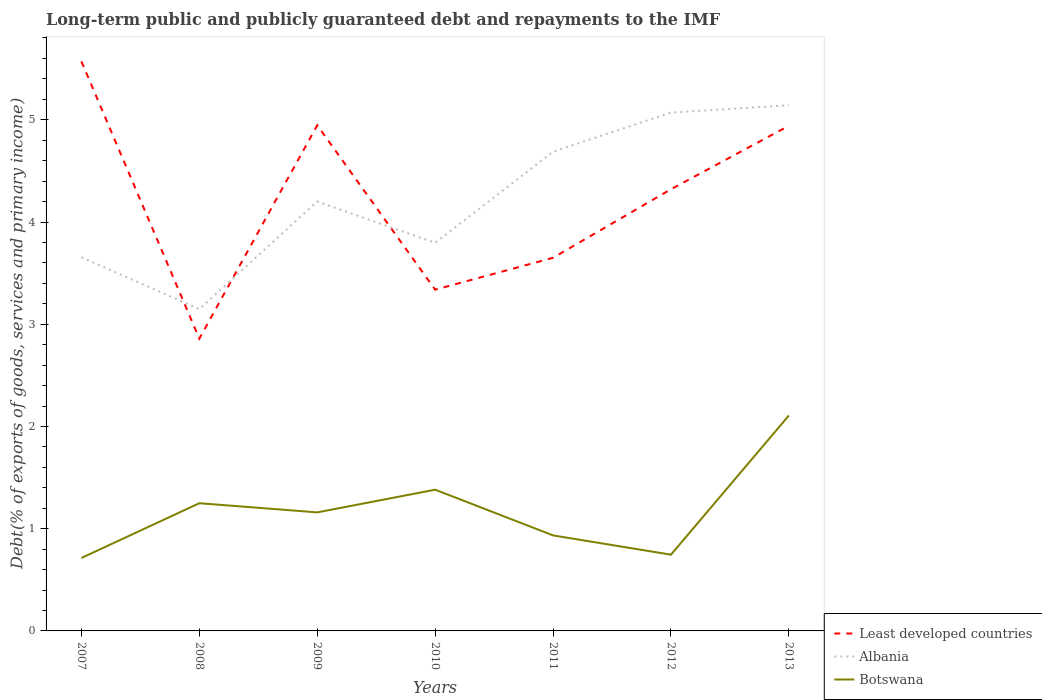Across all years, what is the maximum debt and repayments in Albania?
Ensure brevity in your answer.  3.15. What is the total debt and repayments in Botswana in the graph?
Provide a short and direct response. 0.19. What is the difference between the highest and the second highest debt and repayments in Least developed countries?
Offer a terse response. 2.71. Is the debt and repayments in Albania strictly greater than the debt and repayments in Least developed countries over the years?
Offer a very short reply. No. Does the graph contain any zero values?
Keep it short and to the point. No. Does the graph contain grids?
Offer a terse response. No. Where does the legend appear in the graph?
Offer a very short reply. Bottom right. What is the title of the graph?
Ensure brevity in your answer.  Long-term public and publicly guaranteed debt and repayments to the IMF. What is the label or title of the Y-axis?
Ensure brevity in your answer.  Debt(% of exports of goods, services and primary income). What is the Debt(% of exports of goods, services and primary income) in Least developed countries in 2007?
Make the answer very short. 5.57. What is the Debt(% of exports of goods, services and primary income) of Albania in 2007?
Your answer should be compact. 3.66. What is the Debt(% of exports of goods, services and primary income) in Botswana in 2007?
Your response must be concise. 0.71. What is the Debt(% of exports of goods, services and primary income) in Least developed countries in 2008?
Offer a very short reply. 2.86. What is the Debt(% of exports of goods, services and primary income) in Albania in 2008?
Make the answer very short. 3.15. What is the Debt(% of exports of goods, services and primary income) in Botswana in 2008?
Your answer should be compact. 1.25. What is the Debt(% of exports of goods, services and primary income) in Least developed countries in 2009?
Your response must be concise. 4.95. What is the Debt(% of exports of goods, services and primary income) of Albania in 2009?
Offer a terse response. 4.2. What is the Debt(% of exports of goods, services and primary income) of Botswana in 2009?
Your response must be concise. 1.16. What is the Debt(% of exports of goods, services and primary income) in Least developed countries in 2010?
Offer a very short reply. 3.34. What is the Debt(% of exports of goods, services and primary income) in Albania in 2010?
Provide a succinct answer. 3.8. What is the Debt(% of exports of goods, services and primary income) in Botswana in 2010?
Keep it short and to the point. 1.38. What is the Debt(% of exports of goods, services and primary income) in Least developed countries in 2011?
Ensure brevity in your answer.  3.65. What is the Debt(% of exports of goods, services and primary income) of Albania in 2011?
Your answer should be compact. 4.69. What is the Debt(% of exports of goods, services and primary income) in Botswana in 2011?
Keep it short and to the point. 0.93. What is the Debt(% of exports of goods, services and primary income) of Least developed countries in 2012?
Ensure brevity in your answer.  4.32. What is the Debt(% of exports of goods, services and primary income) in Albania in 2012?
Make the answer very short. 5.07. What is the Debt(% of exports of goods, services and primary income) of Botswana in 2012?
Give a very brief answer. 0.75. What is the Debt(% of exports of goods, services and primary income) of Least developed countries in 2013?
Give a very brief answer. 4.94. What is the Debt(% of exports of goods, services and primary income) in Albania in 2013?
Provide a short and direct response. 5.14. What is the Debt(% of exports of goods, services and primary income) in Botswana in 2013?
Your answer should be compact. 2.11. Across all years, what is the maximum Debt(% of exports of goods, services and primary income) in Least developed countries?
Provide a succinct answer. 5.57. Across all years, what is the maximum Debt(% of exports of goods, services and primary income) in Albania?
Your response must be concise. 5.14. Across all years, what is the maximum Debt(% of exports of goods, services and primary income) of Botswana?
Make the answer very short. 2.11. Across all years, what is the minimum Debt(% of exports of goods, services and primary income) of Least developed countries?
Offer a terse response. 2.86. Across all years, what is the minimum Debt(% of exports of goods, services and primary income) in Albania?
Your response must be concise. 3.15. Across all years, what is the minimum Debt(% of exports of goods, services and primary income) in Botswana?
Keep it short and to the point. 0.71. What is the total Debt(% of exports of goods, services and primary income) in Least developed countries in the graph?
Provide a succinct answer. 29.63. What is the total Debt(% of exports of goods, services and primary income) of Albania in the graph?
Offer a terse response. 29.7. What is the total Debt(% of exports of goods, services and primary income) of Botswana in the graph?
Your response must be concise. 8.29. What is the difference between the Debt(% of exports of goods, services and primary income) in Least developed countries in 2007 and that in 2008?
Offer a very short reply. 2.71. What is the difference between the Debt(% of exports of goods, services and primary income) in Albania in 2007 and that in 2008?
Offer a very short reply. 0.51. What is the difference between the Debt(% of exports of goods, services and primary income) of Botswana in 2007 and that in 2008?
Your response must be concise. -0.54. What is the difference between the Debt(% of exports of goods, services and primary income) of Least developed countries in 2007 and that in 2009?
Provide a short and direct response. 0.62. What is the difference between the Debt(% of exports of goods, services and primary income) in Albania in 2007 and that in 2009?
Make the answer very short. -0.55. What is the difference between the Debt(% of exports of goods, services and primary income) of Botswana in 2007 and that in 2009?
Provide a short and direct response. -0.45. What is the difference between the Debt(% of exports of goods, services and primary income) of Least developed countries in 2007 and that in 2010?
Your response must be concise. 2.23. What is the difference between the Debt(% of exports of goods, services and primary income) in Albania in 2007 and that in 2010?
Give a very brief answer. -0.14. What is the difference between the Debt(% of exports of goods, services and primary income) in Botswana in 2007 and that in 2010?
Provide a short and direct response. -0.67. What is the difference between the Debt(% of exports of goods, services and primary income) of Least developed countries in 2007 and that in 2011?
Your response must be concise. 1.92. What is the difference between the Debt(% of exports of goods, services and primary income) in Albania in 2007 and that in 2011?
Provide a succinct answer. -1.03. What is the difference between the Debt(% of exports of goods, services and primary income) of Botswana in 2007 and that in 2011?
Your answer should be very brief. -0.22. What is the difference between the Debt(% of exports of goods, services and primary income) of Least developed countries in 2007 and that in 2012?
Ensure brevity in your answer.  1.25. What is the difference between the Debt(% of exports of goods, services and primary income) of Albania in 2007 and that in 2012?
Give a very brief answer. -1.42. What is the difference between the Debt(% of exports of goods, services and primary income) of Botswana in 2007 and that in 2012?
Give a very brief answer. -0.03. What is the difference between the Debt(% of exports of goods, services and primary income) of Least developed countries in 2007 and that in 2013?
Offer a very short reply. 0.63. What is the difference between the Debt(% of exports of goods, services and primary income) of Albania in 2007 and that in 2013?
Offer a terse response. -1.49. What is the difference between the Debt(% of exports of goods, services and primary income) in Botswana in 2007 and that in 2013?
Your answer should be very brief. -1.39. What is the difference between the Debt(% of exports of goods, services and primary income) in Least developed countries in 2008 and that in 2009?
Keep it short and to the point. -2.09. What is the difference between the Debt(% of exports of goods, services and primary income) in Albania in 2008 and that in 2009?
Make the answer very short. -1.05. What is the difference between the Debt(% of exports of goods, services and primary income) of Botswana in 2008 and that in 2009?
Offer a very short reply. 0.09. What is the difference between the Debt(% of exports of goods, services and primary income) in Least developed countries in 2008 and that in 2010?
Your response must be concise. -0.48. What is the difference between the Debt(% of exports of goods, services and primary income) of Albania in 2008 and that in 2010?
Keep it short and to the point. -0.65. What is the difference between the Debt(% of exports of goods, services and primary income) of Botswana in 2008 and that in 2010?
Make the answer very short. -0.13. What is the difference between the Debt(% of exports of goods, services and primary income) of Least developed countries in 2008 and that in 2011?
Your response must be concise. -0.79. What is the difference between the Debt(% of exports of goods, services and primary income) in Albania in 2008 and that in 2011?
Offer a terse response. -1.54. What is the difference between the Debt(% of exports of goods, services and primary income) in Botswana in 2008 and that in 2011?
Ensure brevity in your answer.  0.31. What is the difference between the Debt(% of exports of goods, services and primary income) in Least developed countries in 2008 and that in 2012?
Ensure brevity in your answer.  -1.46. What is the difference between the Debt(% of exports of goods, services and primary income) of Albania in 2008 and that in 2012?
Your answer should be compact. -1.92. What is the difference between the Debt(% of exports of goods, services and primary income) of Botswana in 2008 and that in 2012?
Your response must be concise. 0.5. What is the difference between the Debt(% of exports of goods, services and primary income) in Least developed countries in 2008 and that in 2013?
Offer a very short reply. -2.08. What is the difference between the Debt(% of exports of goods, services and primary income) in Albania in 2008 and that in 2013?
Your answer should be compact. -1.99. What is the difference between the Debt(% of exports of goods, services and primary income) of Botswana in 2008 and that in 2013?
Ensure brevity in your answer.  -0.86. What is the difference between the Debt(% of exports of goods, services and primary income) in Least developed countries in 2009 and that in 2010?
Give a very brief answer. 1.61. What is the difference between the Debt(% of exports of goods, services and primary income) of Albania in 2009 and that in 2010?
Provide a short and direct response. 0.4. What is the difference between the Debt(% of exports of goods, services and primary income) of Botswana in 2009 and that in 2010?
Provide a succinct answer. -0.22. What is the difference between the Debt(% of exports of goods, services and primary income) of Least developed countries in 2009 and that in 2011?
Provide a short and direct response. 1.3. What is the difference between the Debt(% of exports of goods, services and primary income) of Albania in 2009 and that in 2011?
Your answer should be very brief. -0.49. What is the difference between the Debt(% of exports of goods, services and primary income) of Botswana in 2009 and that in 2011?
Make the answer very short. 0.23. What is the difference between the Debt(% of exports of goods, services and primary income) in Least developed countries in 2009 and that in 2012?
Ensure brevity in your answer.  0.63. What is the difference between the Debt(% of exports of goods, services and primary income) in Albania in 2009 and that in 2012?
Give a very brief answer. -0.87. What is the difference between the Debt(% of exports of goods, services and primary income) in Botswana in 2009 and that in 2012?
Your answer should be compact. 0.41. What is the difference between the Debt(% of exports of goods, services and primary income) in Least developed countries in 2009 and that in 2013?
Your response must be concise. 0. What is the difference between the Debt(% of exports of goods, services and primary income) of Albania in 2009 and that in 2013?
Offer a very short reply. -0.94. What is the difference between the Debt(% of exports of goods, services and primary income) of Botswana in 2009 and that in 2013?
Offer a very short reply. -0.95. What is the difference between the Debt(% of exports of goods, services and primary income) in Least developed countries in 2010 and that in 2011?
Provide a succinct answer. -0.31. What is the difference between the Debt(% of exports of goods, services and primary income) of Albania in 2010 and that in 2011?
Offer a terse response. -0.89. What is the difference between the Debt(% of exports of goods, services and primary income) of Botswana in 2010 and that in 2011?
Your answer should be very brief. 0.45. What is the difference between the Debt(% of exports of goods, services and primary income) in Least developed countries in 2010 and that in 2012?
Make the answer very short. -0.98. What is the difference between the Debt(% of exports of goods, services and primary income) of Albania in 2010 and that in 2012?
Your response must be concise. -1.27. What is the difference between the Debt(% of exports of goods, services and primary income) in Botswana in 2010 and that in 2012?
Your answer should be compact. 0.64. What is the difference between the Debt(% of exports of goods, services and primary income) of Least developed countries in 2010 and that in 2013?
Provide a short and direct response. -1.6. What is the difference between the Debt(% of exports of goods, services and primary income) of Albania in 2010 and that in 2013?
Your answer should be compact. -1.35. What is the difference between the Debt(% of exports of goods, services and primary income) of Botswana in 2010 and that in 2013?
Give a very brief answer. -0.73. What is the difference between the Debt(% of exports of goods, services and primary income) of Least developed countries in 2011 and that in 2012?
Your answer should be compact. -0.67. What is the difference between the Debt(% of exports of goods, services and primary income) in Albania in 2011 and that in 2012?
Offer a very short reply. -0.38. What is the difference between the Debt(% of exports of goods, services and primary income) of Botswana in 2011 and that in 2012?
Your answer should be very brief. 0.19. What is the difference between the Debt(% of exports of goods, services and primary income) in Least developed countries in 2011 and that in 2013?
Provide a short and direct response. -1.29. What is the difference between the Debt(% of exports of goods, services and primary income) in Albania in 2011 and that in 2013?
Your response must be concise. -0.45. What is the difference between the Debt(% of exports of goods, services and primary income) of Botswana in 2011 and that in 2013?
Offer a very short reply. -1.17. What is the difference between the Debt(% of exports of goods, services and primary income) in Least developed countries in 2012 and that in 2013?
Offer a very short reply. -0.62. What is the difference between the Debt(% of exports of goods, services and primary income) of Albania in 2012 and that in 2013?
Give a very brief answer. -0.07. What is the difference between the Debt(% of exports of goods, services and primary income) of Botswana in 2012 and that in 2013?
Provide a short and direct response. -1.36. What is the difference between the Debt(% of exports of goods, services and primary income) in Least developed countries in 2007 and the Debt(% of exports of goods, services and primary income) in Albania in 2008?
Provide a short and direct response. 2.42. What is the difference between the Debt(% of exports of goods, services and primary income) in Least developed countries in 2007 and the Debt(% of exports of goods, services and primary income) in Botswana in 2008?
Your response must be concise. 4.32. What is the difference between the Debt(% of exports of goods, services and primary income) in Albania in 2007 and the Debt(% of exports of goods, services and primary income) in Botswana in 2008?
Your response must be concise. 2.41. What is the difference between the Debt(% of exports of goods, services and primary income) in Least developed countries in 2007 and the Debt(% of exports of goods, services and primary income) in Albania in 2009?
Make the answer very short. 1.37. What is the difference between the Debt(% of exports of goods, services and primary income) in Least developed countries in 2007 and the Debt(% of exports of goods, services and primary income) in Botswana in 2009?
Provide a succinct answer. 4.41. What is the difference between the Debt(% of exports of goods, services and primary income) in Albania in 2007 and the Debt(% of exports of goods, services and primary income) in Botswana in 2009?
Offer a very short reply. 2.5. What is the difference between the Debt(% of exports of goods, services and primary income) of Least developed countries in 2007 and the Debt(% of exports of goods, services and primary income) of Albania in 2010?
Offer a terse response. 1.77. What is the difference between the Debt(% of exports of goods, services and primary income) in Least developed countries in 2007 and the Debt(% of exports of goods, services and primary income) in Botswana in 2010?
Make the answer very short. 4.19. What is the difference between the Debt(% of exports of goods, services and primary income) of Albania in 2007 and the Debt(% of exports of goods, services and primary income) of Botswana in 2010?
Make the answer very short. 2.27. What is the difference between the Debt(% of exports of goods, services and primary income) in Least developed countries in 2007 and the Debt(% of exports of goods, services and primary income) in Albania in 2011?
Your response must be concise. 0.88. What is the difference between the Debt(% of exports of goods, services and primary income) in Least developed countries in 2007 and the Debt(% of exports of goods, services and primary income) in Botswana in 2011?
Provide a short and direct response. 4.64. What is the difference between the Debt(% of exports of goods, services and primary income) of Albania in 2007 and the Debt(% of exports of goods, services and primary income) of Botswana in 2011?
Your answer should be very brief. 2.72. What is the difference between the Debt(% of exports of goods, services and primary income) in Least developed countries in 2007 and the Debt(% of exports of goods, services and primary income) in Albania in 2012?
Ensure brevity in your answer.  0.5. What is the difference between the Debt(% of exports of goods, services and primary income) in Least developed countries in 2007 and the Debt(% of exports of goods, services and primary income) in Botswana in 2012?
Your answer should be very brief. 4.83. What is the difference between the Debt(% of exports of goods, services and primary income) in Albania in 2007 and the Debt(% of exports of goods, services and primary income) in Botswana in 2012?
Offer a very short reply. 2.91. What is the difference between the Debt(% of exports of goods, services and primary income) of Least developed countries in 2007 and the Debt(% of exports of goods, services and primary income) of Albania in 2013?
Ensure brevity in your answer.  0.43. What is the difference between the Debt(% of exports of goods, services and primary income) in Least developed countries in 2007 and the Debt(% of exports of goods, services and primary income) in Botswana in 2013?
Ensure brevity in your answer.  3.46. What is the difference between the Debt(% of exports of goods, services and primary income) of Albania in 2007 and the Debt(% of exports of goods, services and primary income) of Botswana in 2013?
Ensure brevity in your answer.  1.55. What is the difference between the Debt(% of exports of goods, services and primary income) in Least developed countries in 2008 and the Debt(% of exports of goods, services and primary income) in Albania in 2009?
Make the answer very short. -1.34. What is the difference between the Debt(% of exports of goods, services and primary income) in Least developed countries in 2008 and the Debt(% of exports of goods, services and primary income) in Botswana in 2009?
Offer a terse response. 1.7. What is the difference between the Debt(% of exports of goods, services and primary income) in Albania in 2008 and the Debt(% of exports of goods, services and primary income) in Botswana in 2009?
Your answer should be very brief. 1.99. What is the difference between the Debt(% of exports of goods, services and primary income) of Least developed countries in 2008 and the Debt(% of exports of goods, services and primary income) of Albania in 2010?
Give a very brief answer. -0.94. What is the difference between the Debt(% of exports of goods, services and primary income) in Least developed countries in 2008 and the Debt(% of exports of goods, services and primary income) in Botswana in 2010?
Offer a very short reply. 1.48. What is the difference between the Debt(% of exports of goods, services and primary income) of Albania in 2008 and the Debt(% of exports of goods, services and primary income) of Botswana in 2010?
Your response must be concise. 1.77. What is the difference between the Debt(% of exports of goods, services and primary income) of Least developed countries in 2008 and the Debt(% of exports of goods, services and primary income) of Albania in 2011?
Ensure brevity in your answer.  -1.83. What is the difference between the Debt(% of exports of goods, services and primary income) of Least developed countries in 2008 and the Debt(% of exports of goods, services and primary income) of Botswana in 2011?
Provide a succinct answer. 1.92. What is the difference between the Debt(% of exports of goods, services and primary income) in Albania in 2008 and the Debt(% of exports of goods, services and primary income) in Botswana in 2011?
Your response must be concise. 2.21. What is the difference between the Debt(% of exports of goods, services and primary income) in Least developed countries in 2008 and the Debt(% of exports of goods, services and primary income) in Albania in 2012?
Keep it short and to the point. -2.21. What is the difference between the Debt(% of exports of goods, services and primary income) in Least developed countries in 2008 and the Debt(% of exports of goods, services and primary income) in Botswana in 2012?
Keep it short and to the point. 2.11. What is the difference between the Debt(% of exports of goods, services and primary income) of Albania in 2008 and the Debt(% of exports of goods, services and primary income) of Botswana in 2012?
Make the answer very short. 2.4. What is the difference between the Debt(% of exports of goods, services and primary income) in Least developed countries in 2008 and the Debt(% of exports of goods, services and primary income) in Albania in 2013?
Your response must be concise. -2.28. What is the difference between the Debt(% of exports of goods, services and primary income) of Least developed countries in 2008 and the Debt(% of exports of goods, services and primary income) of Botswana in 2013?
Provide a succinct answer. 0.75. What is the difference between the Debt(% of exports of goods, services and primary income) in Albania in 2008 and the Debt(% of exports of goods, services and primary income) in Botswana in 2013?
Provide a succinct answer. 1.04. What is the difference between the Debt(% of exports of goods, services and primary income) of Least developed countries in 2009 and the Debt(% of exports of goods, services and primary income) of Albania in 2010?
Keep it short and to the point. 1.15. What is the difference between the Debt(% of exports of goods, services and primary income) in Least developed countries in 2009 and the Debt(% of exports of goods, services and primary income) in Botswana in 2010?
Offer a terse response. 3.56. What is the difference between the Debt(% of exports of goods, services and primary income) of Albania in 2009 and the Debt(% of exports of goods, services and primary income) of Botswana in 2010?
Offer a very short reply. 2.82. What is the difference between the Debt(% of exports of goods, services and primary income) of Least developed countries in 2009 and the Debt(% of exports of goods, services and primary income) of Albania in 2011?
Your response must be concise. 0.26. What is the difference between the Debt(% of exports of goods, services and primary income) of Least developed countries in 2009 and the Debt(% of exports of goods, services and primary income) of Botswana in 2011?
Offer a very short reply. 4.01. What is the difference between the Debt(% of exports of goods, services and primary income) of Albania in 2009 and the Debt(% of exports of goods, services and primary income) of Botswana in 2011?
Keep it short and to the point. 3.27. What is the difference between the Debt(% of exports of goods, services and primary income) in Least developed countries in 2009 and the Debt(% of exports of goods, services and primary income) in Albania in 2012?
Your answer should be very brief. -0.12. What is the difference between the Debt(% of exports of goods, services and primary income) in Least developed countries in 2009 and the Debt(% of exports of goods, services and primary income) in Botswana in 2012?
Ensure brevity in your answer.  4.2. What is the difference between the Debt(% of exports of goods, services and primary income) of Albania in 2009 and the Debt(% of exports of goods, services and primary income) of Botswana in 2012?
Your answer should be very brief. 3.45. What is the difference between the Debt(% of exports of goods, services and primary income) in Least developed countries in 2009 and the Debt(% of exports of goods, services and primary income) in Albania in 2013?
Offer a very short reply. -0.2. What is the difference between the Debt(% of exports of goods, services and primary income) in Least developed countries in 2009 and the Debt(% of exports of goods, services and primary income) in Botswana in 2013?
Offer a very short reply. 2.84. What is the difference between the Debt(% of exports of goods, services and primary income) of Albania in 2009 and the Debt(% of exports of goods, services and primary income) of Botswana in 2013?
Your answer should be compact. 2.09. What is the difference between the Debt(% of exports of goods, services and primary income) in Least developed countries in 2010 and the Debt(% of exports of goods, services and primary income) in Albania in 2011?
Provide a succinct answer. -1.35. What is the difference between the Debt(% of exports of goods, services and primary income) of Least developed countries in 2010 and the Debt(% of exports of goods, services and primary income) of Botswana in 2011?
Give a very brief answer. 2.4. What is the difference between the Debt(% of exports of goods, services and primary income) in Albania in 2010 and the Debt(% of exports of goods, services and primary income) in Botswana in 2011?
Ensure brevity in your answer.  2.86. What is the difference between the Debt(% of exports of goods, services and primary income) in Least developed countries in 2010 and the Debt(% of exports of goods, services and primary income) in Albania in 2012?
Your answer should be compact. -1.73. What is the difference between the Debt(% of exports of goods, services and primary income) of Least developed countries in 2010 and the Debt(% of exports of goods, services and primary income) of Botswana in 2012?
Keep it short and to the point. 2.59. What is the difference between the Debt(% of exports of goods, services and primary income) of Albania in 2010 and the Debt(% of exports of goods, services and primary income) of Botswana in 2012?
Your answer should be very brief. 3.05. What is the difference between the Debt(% of exports of goods, services and primary income) of Least developed countries in 2010 and the Debt(% of exports of goods, services and primary income) of Albania in 2013?
Make the answer very short. -1.8. What is the difference between the Debt(% of exports of goods, services and primary income) in Least developed countries in 2010 and the Debt(% of exports of goods, services and primary income) in Botswana in 2013?
Keep it short and to the point. 1.23. What is the difference between the Debt(% of exports of goods, services and primary income) of Albania in 2010 and the Debt(% of exports of goods, services and primary income) of Botswana in 2013?
Your answer should be very brief. 1.69. What is the difference between the Debt(% of exports of goods, services and primary income) in Least developed countries in 2011 and the Debt(% of exports of goods, services and primary income) in Albania in 2012?
Keep it short and to the point. -1.42. What is the difference between the Debt(% of exports of goods, services and primary income) in Least developed countries in 2011 and the Debt(% of exports of goods, services and primary income) in Botswana in 2012?
Give a very brief answer. 2.9. What is the difference between the Debt(% of exports of goods, services and primary income) in Albania in 2011 and the Debt(% of exports of goods, services and primary income) in Botswana in 2012?
Offer a terse response. 3.94. What is the difference between the Debt(% of exports of goods, services and primary income) in Least developed countries in 2011 and the Debt(% of exports of goods, services and primary income) in Albania in 2013?
Offer a very short reply. -1.49. What is the difference between the Debt(% of exports of goods, services and primary income) in Least developed countries in 2011 and the Debt(% of exports of goods, services and primary income) in Botswana in 2013?
Provide a short and direct response. 1.54. What is the difference between the Debt(% of exports of goods, services and primary income) of Albania in 2011 and the Debt(% of exports of goods, services and primary income) of Botswana in 2013?
Offer a terse response. 2.58. What is the difference between the Debt(% of exports of goods, services and primary income) of Least developed countries in 2012 and the Debt(% of exports of goods, services and primary income) of Albania in 2013?
Offer a very short reply. -0.82. What is the difference between the Debt(% of exports of goods, services and primary income) in Least developed countries in 2012 and the Debt(% of exports of goods, services and primary income) in Botswana in 2013?
Your answer should be compact. 2.21. What is the difference between the Debt(% of exports of goods, services and primary income) of Albania in 2012 and the Debt(% of exports of goods, services and primary income) of Botswana in 2013?
Your answer should be compact. 2.96. What is the average Debt(% of exports of goods, services and primary income) of Least developed countries per year?
Give a very brief answer. 4.23. What is the average Debt(% of exports of goods, services and primary income) of Albania per year?
Provide a succinct answer. 4.24. What is the average Debt(% of exports of goods, services and primary income) of Botswana per year?
Make the answer very short. 1.18. In the year 2007, what is the difference between the Debt(% of exports of goods, services and primary income) of Least developed countries and Debt(% of exports of goods, services and primary income) of Albania?
Keep it short and to the point. 1.92. In the year 2007, what is the difference between the Debt(% of exports of goods, services and primary income) of Least developed countries and Debt(% of exports of goods, services and primary income) of Botswana?
Provide a succinct answer. 4.86. In the year 2007, what is the difference between the Debt(% of exports of goods, services and primary income) in Albania and Debt(% of exports of goods, services and primary income) in Botswana?
Provide a succinct answer. 2.94. In the year 2008, what is the difference between the Debt(% of exports of goods, services and primary income) in Least developed countries and Debt(% of exports of goods, services and primary income) in Albania?
Provide a short and direct response. -0.29. In the year 2008, what is the difference between the Debt(% of exports of goods, services and primary income) of Least developed countries and Debt(% of exports of goods, services and primary income) of Botswana?
Your answer should be very brief. 1.61. In the year 2008, what is the difference between the Debt(% of exports of goods, services and primary income) in Albania and Debt(% of exports of goods, services and primary income) in Botswana?
Keep it short and to the point. 1.9. In the year 2009, what is the difference between the Debt(% of exports of goods, services and primary income) of Least developed countries and Debt(% of exports of goods, services and primary income) of Albania?
Your answer should be very brief. 0.75. In the year 2009, what is the difference between the Debt(% of exports of goods, services and primary income) in Least developed countries and Debt(% of exports of goods, services and primary income) in Botswana?
Provide a short and direct response. 3.79. In the year 2009, what is the difference between the Debt(% of exports of goods, services and primary income) of Albania and Debt(% of exports of goods, services and primary income) of Botswana?
Provide a short and direct response. 3.04. In the year 2010, what is the difference between the Debt(% of exports of goods, services and primary income) of Least developed countries and Debt(% of exports of goods, services and primary income) of Albania?
Make the answer very short. -0.46. In the year 2010, what is the difference between the Debt(% of exports of goods, services and primary income) in Least developed countries and Debt(% of exports of goods, services and primary income) in Botswana?
Keep it short and to the point. 1.96. In the year 2010, what is the difference between the Debt(% of exports of goods, services and primary income) in Albania and Debt(% of exports of goods, services and primary income) in Botswana?
Your response must be concise. 2.42. In the year 2011, what is the difference between the Debt(% of exports of goods, services and primary income) in Least developed countries and Debt(% of exports of goods, services and primary income) in Albania?
Make the answer very short. -1.04. In the year 2011, what is the difference between the Debt(% of exports of goods, services and primary income) of Least developed countries and Debt(% of exports of goods, services and primary income) of Botswana?
Provide a succinct answer. 2.72. In the year 2011, what is the difference between the Debt(% of exports of goods, services and primary income) in Albania and Debt(% of exports of goods, services and primary income) in Botswana?
Provide a short and direct response. 3.75. In the year 2012, what is the difference between the Debt(% of exports of goods, services and primary income) of Least developed countries and Debt(% of exports of goods, services and primary income) of Albania?
Keep it short and to the point. -0.75. In the year 2012, what is the difference between the Debt(% of exports of goods, services and primary income) of Least developed countries and Debt(% of exports of goods, services and primary income) of Botswana?
Ensure brevity in your answer.  3.57. In the year 2012, what is the difference between the Debt(% of exports of goods, services and primary income) in Albania and Debt(% of exports of goods, services and primary income) in Botswana?
Your response must be concise. 4.32. In the year 2013, what is the difference between the Debt(% of exports of goods, services and primary income) of Least developed countries and Debt(% of exports of goods, services and primary income) of Albania?
Ensure brevity in your answer.  -0.2. In the year 2013, what is the difference between the Debt(% of exports of goods, services and primary income) of Least developed countries and Debt(% of exports of goods, services and primary income) of Botswana?
Your answer should be very brief. 2.83. In the year 2013, what is the difference between the Debt(% of exports of goods, services and primary income) of Albania and Debt(% of exports of goods, services and primary income) of Botswana?
Offer a very short reply. 3.03. What is the ratio of the Debt(% of exports of goods, services and primary income) in Least developed countries in 2007 to that in 2008?
Give a very brief answer. 1.95. What is the ratio of the Debt(% of exports of goods, services and primary income) of Albania in 2007 to that in 2008?
Provide a short and direct response. 1.16. What is the ratio of the Debt(% of exports of goods, services and primary income) in Botswana in 2007 to that in 2008?
Ensure brevity in your answer.  0.57. What is the ratio of the Debt(% of exports of goods, services and primary income) of Least developed countries in 2007 to that in 2009?
Your answer should be very brief. 1.13. What is the ratio of the Debt(% of exports of goods, services and primary income) in Albania in 2007 to that in 2009?
Your answer should be very brief. 0.87. What is the ratio of the Debt(% of exports of goods, services and primary income) in Botswana in 2007 to that in 2009?
Keep it short and to the point. 0.62. What is the ratio of the Debt(% of exports of goods, services and primary income) in Least developed countries in 2007 to that in 2010?
Offer a very short reply. 1.67. What is the ratio of the Debt(% of exports of goods, services and primary income) in Albania in 2007 to that in 2010?
Offer a very short reply. 0.96. What is the ratio of the Debt(% of exports of goods, services and primary income) in Botswana in 2007 to that in 2010?
Offer a terse response. 0.52. What is the ratio of the Debt(% of exports of goods, services and primary income) of Least developed countries in 2007 to that in 2011?
Offer a terse response. 1.53. What is the ratio of the Debt(% of exports of goods, services and primary income) in Albania in 2007 to that in 2011?
Offer a terse response. 0.78. What is the ratio of the Debt(% of exports of goods, services and primary income) in Botswana in 2007 to that in 2011?
Offer a terse response. 0.76. What is the ratio of the Debt(% of exports of goods, services and primary income) of Least developed countries in 2007 to that in 2012?
Offer a very short reply. 1.29. What is the ratio of the Debt(% of exports of goods, services and primary income) in Albania in 2007 to that in 2012?
Offer a terse response. 0.72. What is the ratio of the Debt(% of exports of goods, services and primary income) of Botswana in 2007 to that in 2012?
Keep it short and to the point. 0.96. What is the ratio of the Debt(% of exports of goods, services and primary income) of Least developed countries in 2007 to that in 2013?
Your response must be concise. 1.13. What is the ratio of the Debt(% of exports of goods, services and primary income) of Albania in 2007 to that in 2013?
Your answer should be very brief. 0.71. What is the ratio of the Debt(% of exports of goods, services and primary income) in Botswana in 2007 to that in 2013?
Keep it short and to the point. 0.34. What is the ratio of the Debt(% of exports of goods, services and primary income) in Least developed countries in 2008 to that in 2009?
Keep it short and to the point. 0.58. What is the ratio of the Debt(% of exports of goods, services and primary income) in Albania in 2008 to that in 2009?
Provide a short and direct response. 0.75. What is the ratio of the Debt(% of exports of goods, services and primary income) of Botswana in 2008 to that in 2009?
Offer a terse response. 1.08. What is the ratio of the Debt(% of exports of goods, services and primary income) of Least developed countries in 2008 to that in 2010?
Keep it short and to the point. 0.86. What is the ratio of the Debt(% of exports of goods, services and primary income) in Albania in 2008 to that in 2010?
Offer a terse response. 0.83. What is the ratio of the Debt(% of exports of goods, services and primary income) in Botswana in 2008 to that in 2010?
Give a very brief answer. 0.9. What is the ratio of the Debt(% of exports of goods, services and primary income) in Least developed countries in 2008 to that in 2011?
Offer a very short reply. 0.78. What is the ratio of the Debt(% of exports of goods, services and primary income) of Albania in 2008 to that in 2011?
Ensure brevity in your answer.  0.67. What is the ratio of the Debt(% of exports of goods, services and primary income) in Botswana in 2008 to that in 2011?
Your answer should be compact. 1.34. What is the ratio of the Debt(% of exports of goods, services and primary income) of Least developed countries in 2008 to that in 2012?
Provide a succinct answer. 0.66. What is the ratio of the Debt(% of exports of goods, services and primary income) in Albania in 2008 to that in 2012?
Your response must be concise. 0.62. What is the ratio of the Debt(% of exports of goods, services and primary income) in Botswana in 2008 to that in 2012?
Provide a succinct answer. 1.68. What is the ratio of the Debt(% of exports of goods, services and primary income) in Least developed countries in 2008 to that in 2013?
Your answer should be compact. 0.58. What is the ratio of the Debt(% of exports of goods, services and primary income) in Albania in 2008 to that in 2013?
Make the answer very short. 0.61. What is the ratio of the Debt(% of exports of goods, services and primary income) of Botswana in 2008 to that in 2013?
Your answer should be very brief. 0.59. What is the ratio of the Debt(% of exports of goods, services and primary income) in Least developed countries in 2009 to that in 2010?
Offer a terse response. 1.48. What is the ratio of the Debt(% of exports of goods, services and primary income) of Albania in 2009 to that in 2010?
Make the answer very short. 1.11. What is the ratio of the Debt(% of exports of goods, services and primary income) in Botswana in 2009 to that in 2010?
Offer a very short reply. 0.84. What is the ratio of the Debt(% of exports of goods, services and primary income) of Least developed countries in 2009 to that in 2011?
Make the answer very short. 1.36. What is the ratio of the Debt(% of exports of goods, services and primary income) of Albania in 2009 to that in 2011?
Offer a terse response. 0.9. What is the ratio of the Debt(% of exports of goods, services and primary income) in Botswana in 2009 to that in 2011?
Keep it short and to the point. 1.24. What is the ratio of the Debt(% of exports of goods, services and primary income) of Least developed countries in 2009 to that in 2012?
Your response must be concise. 1.14. What is the ratio of the Debt(% of exports of goods, services and primary income) of Albania in 2009 to that in 2012?
Make the answer very short. 0.83. What is the ratio of the Debt(% of exports of goods, services and primary income) of Botswana in 2009 to that in 2012?
Give a very brief answer. 1.55. What is the ratio of the Debt(% of exports of goods, services and primary income) in Albania in 2009 to that in 2013?
Keep it short and to the point. 0.82. What is the ratio of the Debt(% of exports of goods, services and primary income) in Botswana in 2009 to that in 2013?
Make the answer very short. 0.55. What is the ratio of the Debt(% of exports of goods, services and primary income) in Least developed countries in 2010 to that in 2011?
Keep it short and to the point. 0.91. What is the ratio of the Debt(% of exports of goods, services and primary income) of Albania in 2010 to that in 2011?
Give a very brief answer. 0.81. What is the ratio of the Debt(% of exports of goods, services and primary income) of Botswana in 2010 to that in 2011?
Your answer should be compact. 1.48. What is the ratio of the Debt(% of exports of goods, services and primary income) of Least developed countries in 2010 to that in 2012?
Your response must be concise. 0.77. What is the ratio of the Debt(% of exports of goods, services and primary income) of Albania in 2010 to that in 2012?
Ensure brevity in your answer.  0.75. What is the ratio of the Debt(% of exports of goods, services and primary income) of Botswana in 2010 to that in 2012?
Give a very brief answer. 1.85. What is the ratio of the Debt(% of exports of goods, services and primary income) in Least developed countries in 2010 to that in 2013?
Your response must be concise. 0.68. What is the ratio of the Debt(% of exports of goods, services and primary income) of Albania in 2010 to that in 2013?
Your answer should be very brief. 0.74. What is the ratio of the Debt(% of exports of goods, services and primary income) of Botswana in 2010 to that in 2013?
Provide a short and direct response. 0.66. What is the ratio of the Debt(% of exports of goods, services and primary income) in Least developed countries in 2011 to that in 2012?
Offer a very short reply. 0.84. What is the ratio of the Debt(% of exports of goods, services and primary income) of Albania in 2011 to that in 2012?
Provide a short and direct response. 0.92. What is the ratio of the Debt(% of exports of goods, services and primary income) in Botswana in 2011 to that in 2012?
Give a very brief answer. 1.25. What is the ratio of the Debt(% of exports of goods, services and primary income) of Least developed countries in 2011 to that in 2013?
Make the answer very short. 0.74. What is the ratio of the Debt(% of exports of goods, services and primary income) in Albania in 2011 to that in 2013?
Ensure brevity in your answer.  0.91. What is the ratio of the Debt(% of exports of goods, services and primary income) of Botswana in 2011 to that in 2013?
Offer a terse response. 0.44. What is the ratio of the Debt(% of exports of goods, services and primary income) in Least developed countries in 2012 to that in 2013?
Make the answer very short. 0.87. What is the ratio of the Debt(% of exports of goods, services and primary income) of Albania in 2012 to that in 2013?
Make the answer very short. 0.99. What is the ratio of the Debt(% of exports of goods, services and primary income) of Botswana in 2012 to that in 2013?
Provide a short and direct response. 0.35. What is the difference between the highest and the second highest Debt(% of exports of goods, services and primary income) in Least developed countries?
Offer a terse response. 0.62. What is the difference between the highest and the second highest Debt(% of exports of goods, services and primary income) in Albania?
Make the answer very short. 0.07. What is the difference between the highest and the second highest Debt(% of exports of goods, services and primary income) in Botswana?
Make the answer very short. 0.73. What is the difference between the highest and the lowest Debt(% of exports of goods, services and primary income) of Least developed countries?
Your answer should be very brief. 2.71. What is the difference between the highest and the lowest Debt(% of exports of goods, services and primary income) in Albania?
Provide a succinct answer. 1.99. What is the difference between the highest and the lowest Debt(% of exports of goods, services and primary income) of Botswana?
Provide a short and direct response. 1.39. 